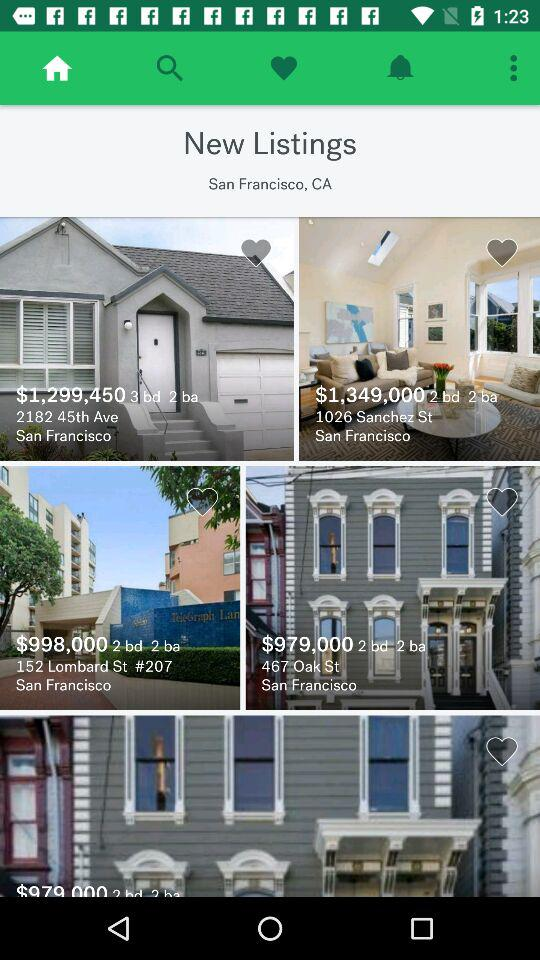What is the location? The location is San Francisco, CA. 